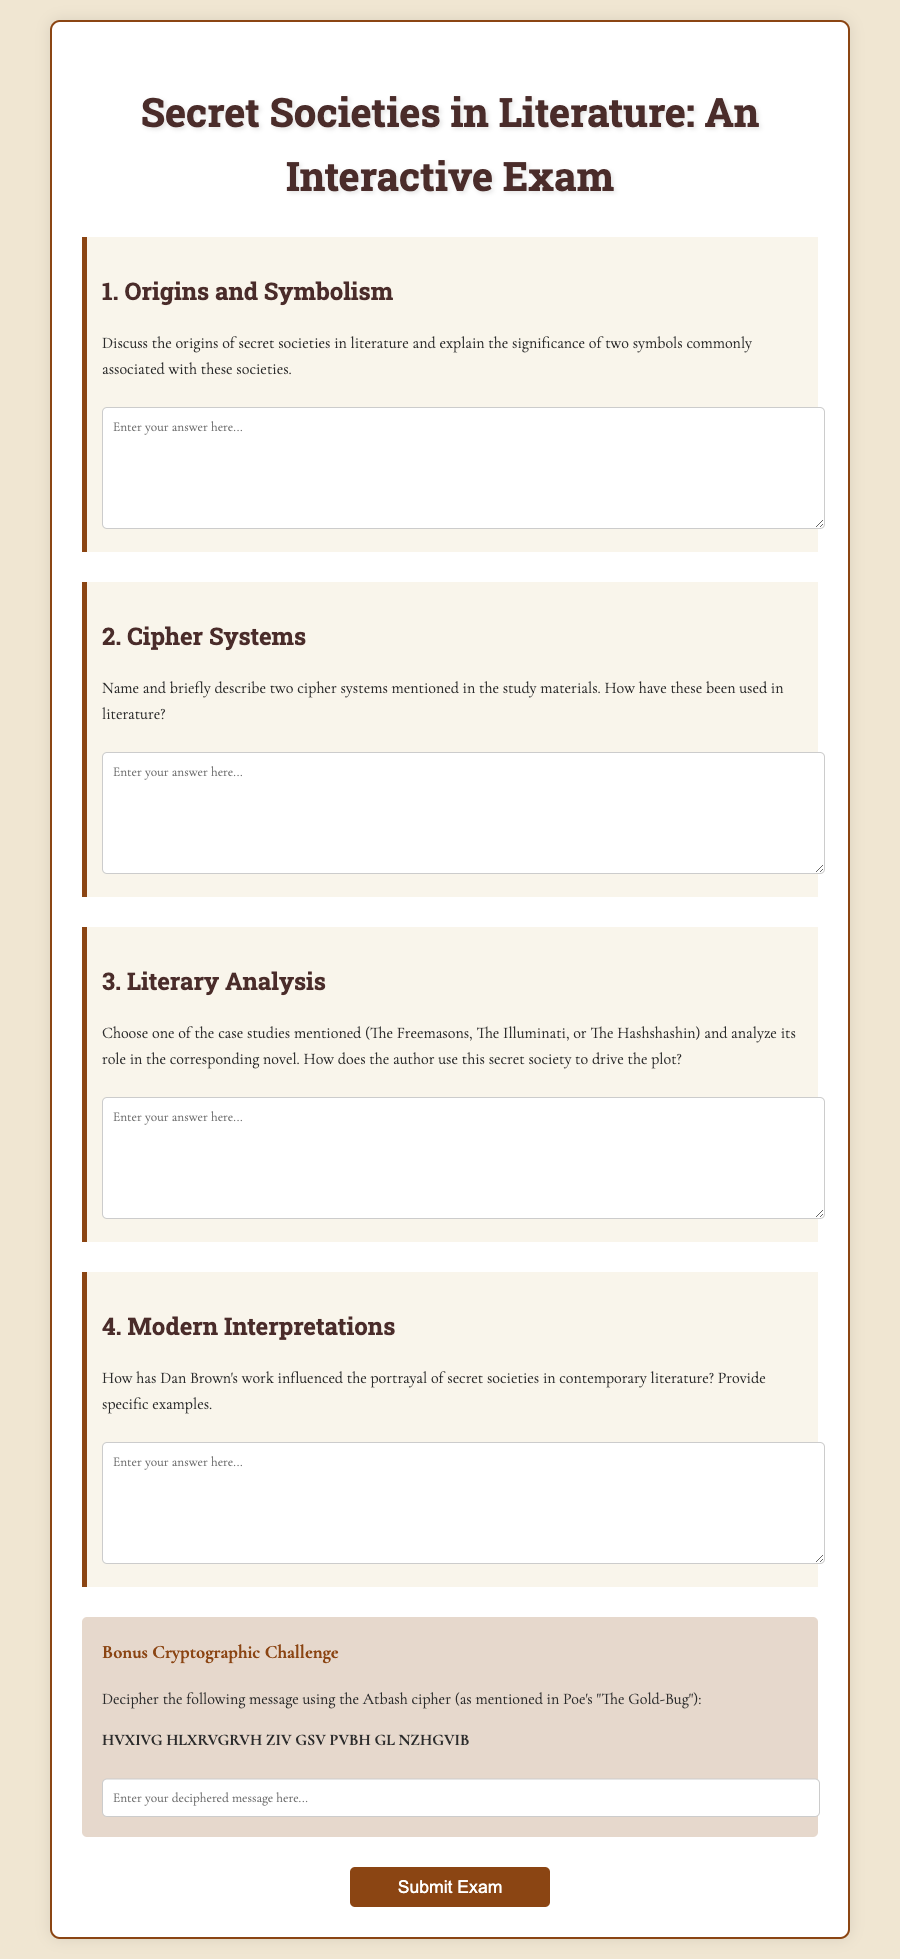1. What is the title of the exam? The title of the exam is displayed at the top of the document and is "Secret Societies in Literature: An Interactive Exam."
Answer: Secret Societies in Literature: An Interactive Exam 2. How many main questions are there in the exam? The document contains four main questions before the bonus challenge, totalling to four.
Answer: 4 3. What is the cipher challenge message to decipher? The message to decipher is presented in a specific format within the bonus section, which reads: "HVXIVG HLXRVGRVH ZIV GSV PVBH GL NZHGVIB."
Answer: HVXIVG HLXRVGRVH ZIV GSV PVBH GL NZHGVIB 4. What literary work is associated with the Atbash cipher? The Atbash cipher is mentioned in connection with Edgar Allan Poe's work, specifically "The Gold-Bug."
Answer: The Gold-Bug 5. What more modern author’s work is mentioned in the document? The document references Dan Brown and his influence on the portrayal of secret societies in contemporary literature.
Answer: Dan Brown 6. Which secret societies are listed as case studies in the exam? The case studies mentioned in the exam include The Freemasons, The Illuminati, and The Hashshashin.
Answer: The Freemasons, The Illuminati, The Hashshashin 7. In what style is the exam text primarily formatted? The text uses specific fonts and styles to create an aesthetically pleasing layout, indicating a designed structure and thematic coherence.
Answer: Aesthetically pleasing layout 8. What type of feedback is promised upon submission of the exam? The document specifies that answers will be reviewed by experts in cryptography after submitting the exam.
Answer: Reviewed by cryptographic experts 